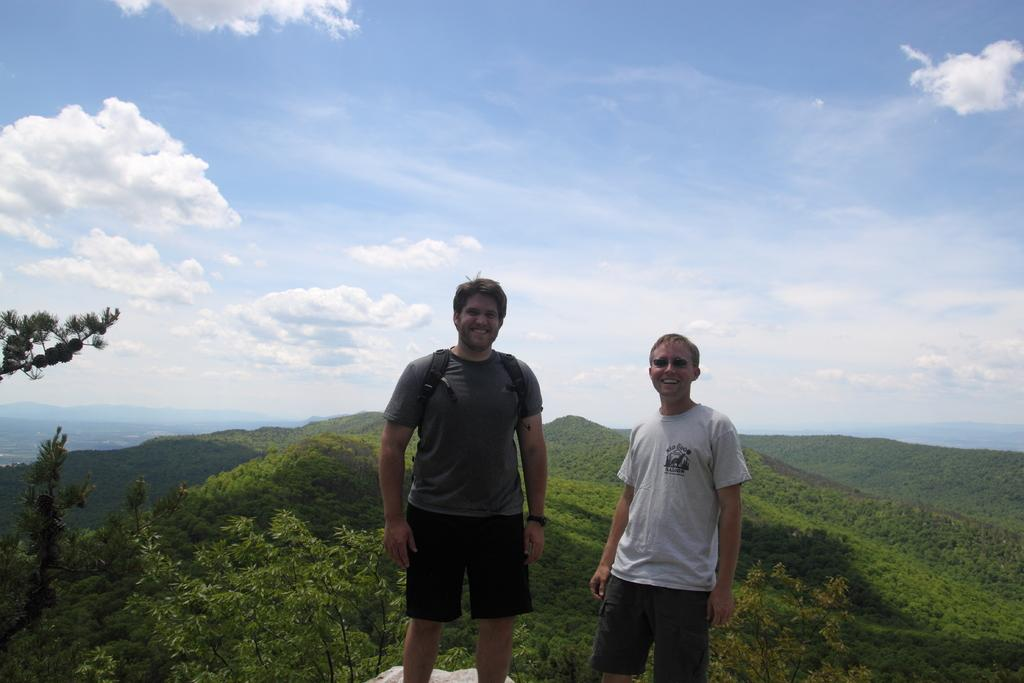How many people are in the image? There are two people standing in the image. What is one person wearing that is visible in the image? One person is wearing a bag. What can be seen in the background of the image? Trees and mountains are visible in the background. What is the color of the sky in the image? The sky is blue and white in color. Can you see any pears being sold by a beggar in the image? There are no pears or beggars present in the image. Is there any smoke coming from the mountains in the image? There is no smoke visible in the image, and the mountains are not actively producing smoke. 